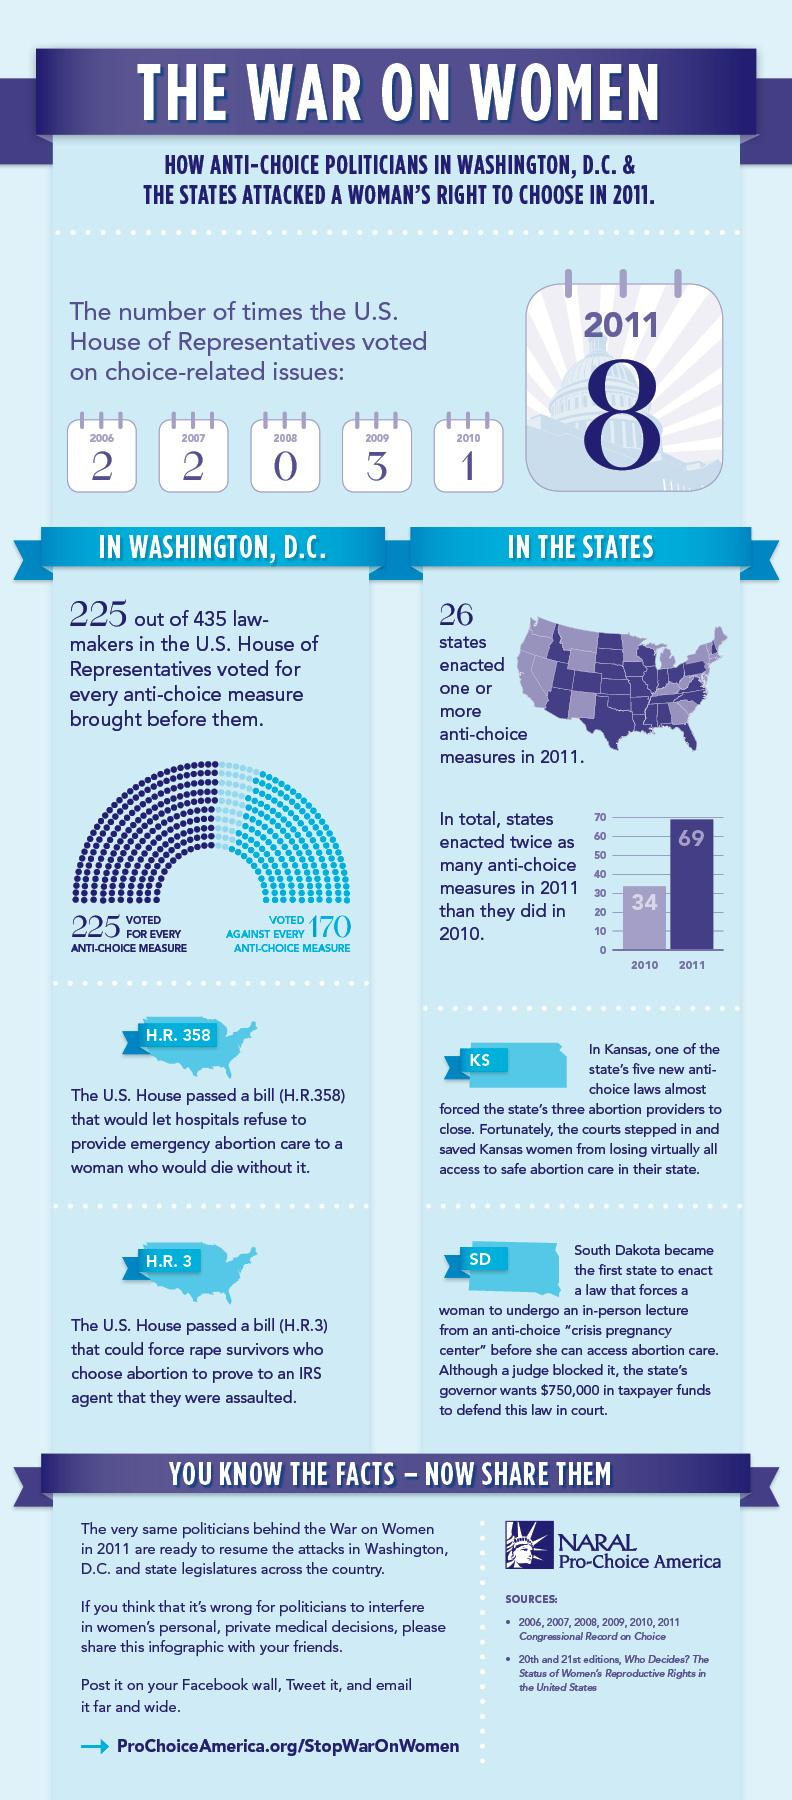Give some essential details in this illustration. Twenty-six states enacted anti-choice measures in 2011. The majority of lawmakers voted for anti-choice measures instead of against them. In the year 2008, no choice-related issues were voted on. The US House of Representatives held a vote on choice-related issues in 2010, and the exact number of times the vote was held is not specified. In 2010, a total of 34 'anti-choice measures' were enacted. 